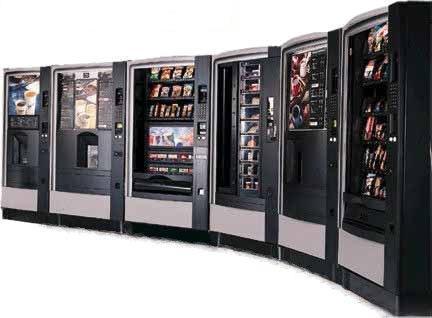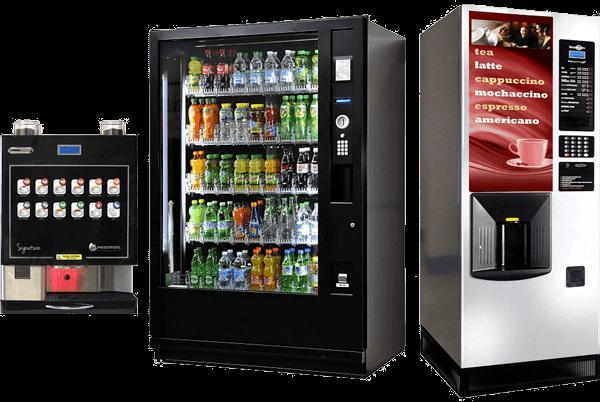The first image is the image on the left, the second image is the image on the right. Evaluate the accuracy of this statement regarding the images: "There is exactly one vending machine in the image on the right.". Is it true? Answer yes or no. No. 